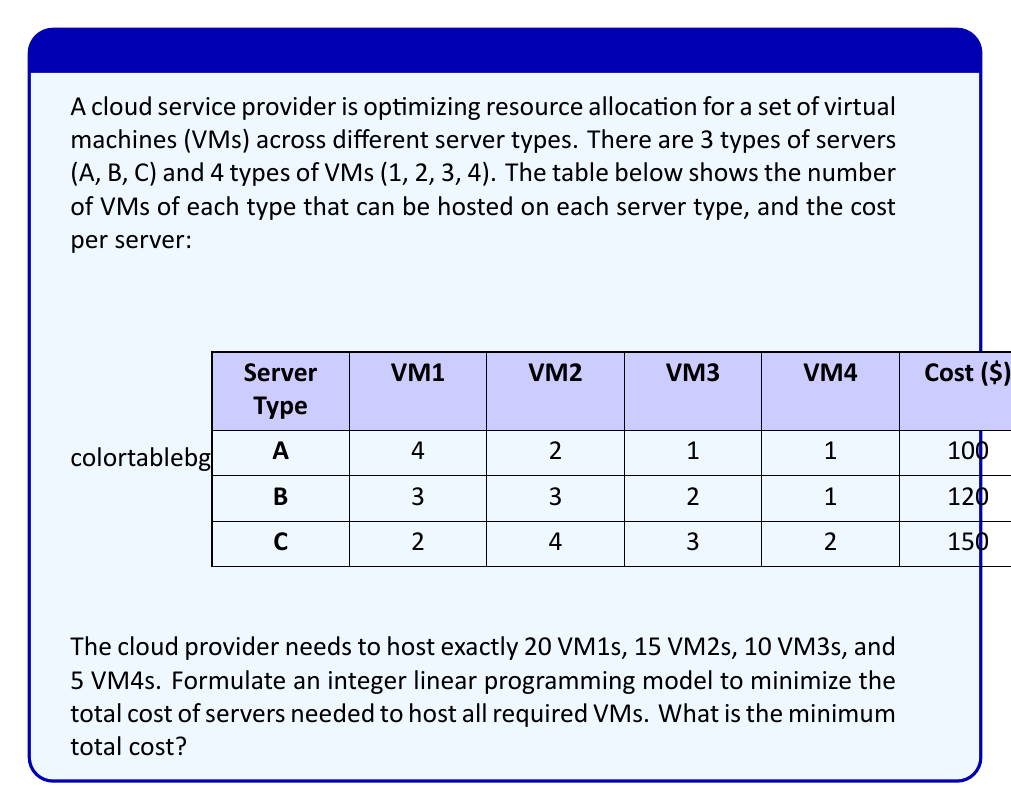Show me your answer to this math problem. To solve this problem, we'll use integer linear programming. Let's define our variables and constraints:

Variables:
Let $x_A$, $x_B$, and $x_C$ be the number of servers of type A, B, and C, respectively.

Objective function:
Minimize the total cost: 
$$Z = 100x_A + 120x_B + 150x_C$$

Constraints:
1. VM1 constraint: $4x_A + 3x_B + 2x_C \geq 20$
2. VM2 constraint: $2x_A + 3x_B + 4x_C \geq 15$
3. VM3 constraint: $x_A + 2x_B + 3x_C \geq 10$
4. VM4 constraint: $x_A + x_B + 2x_C \geq 5$
5. Non-negativity and integer constraints: $x_A, x_B, x_C \geq 0$ and integer

To solve this, we can use an integer linear programming solver. However, we can also solve it manually by considering different combinations:

1. Start with the minimum number of servers needed to satisfy VM4: 3 type A servers ($3 \times 1 = 3$ VM4s) and 1 type C server ($1 \times 2 = 2$ VM4s).
2. This initial solution gives us:
   - 14 VM1s (12 from A, 2 from C)
   - 10 VM2s (6 from A, 4 from C)
   - 6 VM3s (3 from A, 3 from C)
   - 5 VM4s (3 from A, 2 from C)
3. We still need 6 VM1s, 5 VM2s, and 4 VM3s.
4. Adding 2 type B servers satisfies these remaining requirements:
   - 6 VM1s (3 × 2 = 6)
   - 6 VM2s (3 × 2 = 6, which is more than needed)
   - 4 VM3s (2 × 2 = 4)

Final solution:
- 3 type A servers
- 2 type B servers
- 1 type C server

Total cost: $3 \times 100 + 2 \times 120 + 1 \times 150 = 590$

We can verify that this solution satisfies all constraints:
- VM1: $4(3) + 3(2) + 2(1) = 20$
- VM2: $2(3) + 3(2) + 4(1) = 16 \geq 15$
- VM3: $1(3) + 2(2) + 3(1) = 10$
- VM4: $1(3) + 1(2) + 2(1) = 7 \geq 5$
Answer: The minimum total cost to host all required VMs is $590. 